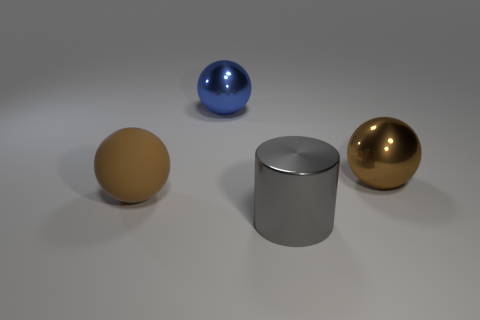Subtract all large rubber balls. How many balls are left? 2 Subtract all blue blocks. How many brown spheres are left? 2 Add 1 red metal objects. How many objects exist? 5 Subtract all blue balls. How many balls are left? 2 Add 1 big yellow rubber spheres. How many big yellow rubber spheres exist? 1 Subtract 0 red cubes. How many objects are left? 4 Subtract all spheres. How many objects are left? 1 Subtract all blue balls. Subtract all yellow cylinders. How many balls are left? 2 Subtract all tiny red metal cylinders. Subtract all big metallic cylinders. How many objects are left? 3 Add 4 gray cylinders. How many gray cylinders are left? 5 